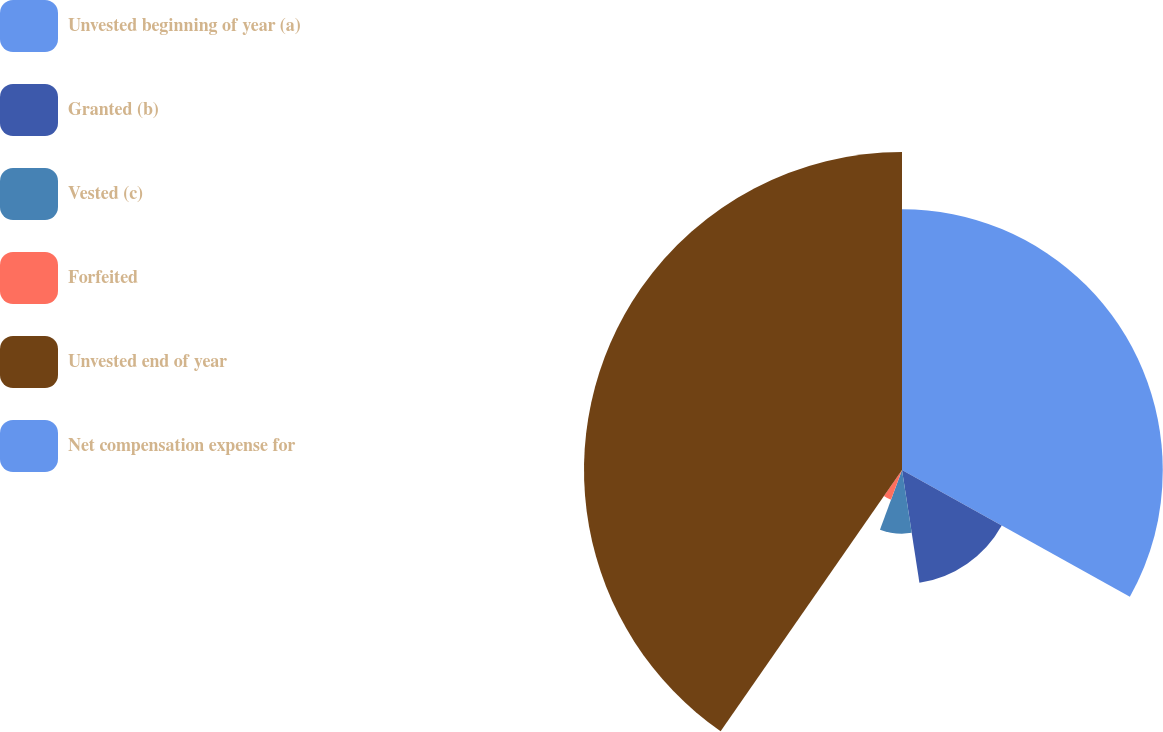Convert chart. <chart><loc_0><loc_0><loc_500><loc_500><pie_chart><fcel>Unvested beginning of year (a)<fcel>Granted (b)<fcel>Vested (c)<fcel>Forfeited<fcel>Unvested end of year<fcel>Net compensation expense for<nl><fcel>33.08%<fcel>14.48%<fcel>8.07%<fcel>4.03%<fcel>40.34%<fcel>0.0%<nl></chart> 